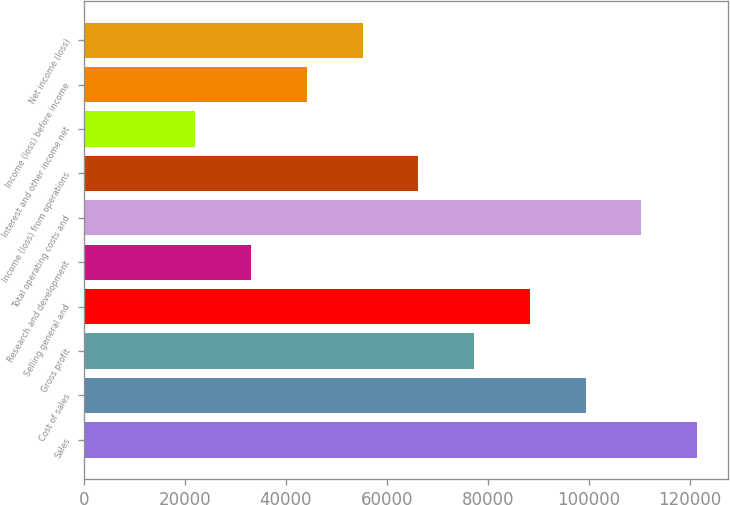<chart> <loc_0><loc_0><loc_500><loc_500><bar_chart><fcel>Sales<fcel>Cost of sales<fcel>Gross profit<fcel>Selling general and<fcel>Research and development<fcel>Total operating costs and<fcel>Income (loss) from operations<fcel>Interest and other income net<fcel>Income (loss) before income<fcel>Net income (loss)<nl><fcel>121407<fcel>99333.1<fcel>77259.3<fcel>88296.2<fcel>33111.7<fcel>110370<fcel>66222.4<fcel>22074.8<fcel>44148.6<fcel>55185.5<nl></chart> 